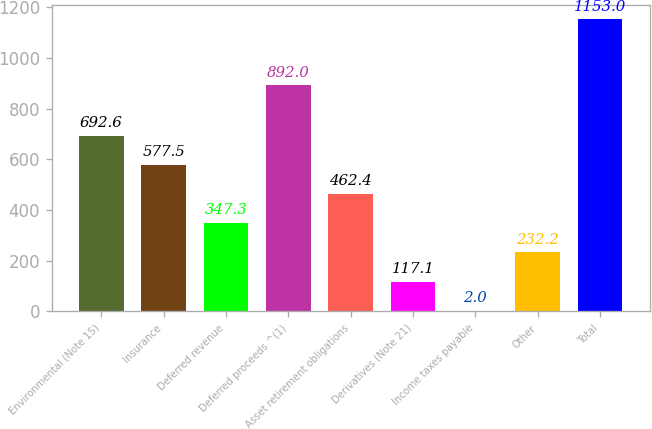<chart> <loc_0><loc_0><loc_500><loc_500><bar_chart><fcel>Environmental (Note 15)<fcel>Insurance<fcel>Deferred revenue<fcel>Deferred proceeds ^(1)<fcel>Asset retirement obligations<fcel>Derivatives (Note 21)<fcel>Income taxes payable<fcel>Other<fcel>Total<nl><fcel>692.6<fcel>577.5<fcel>347.3<fcel>892<fcel>462.4<fcel>117.1<fcel>2<fcel>232.2<fcel>1153<nl></chart> 